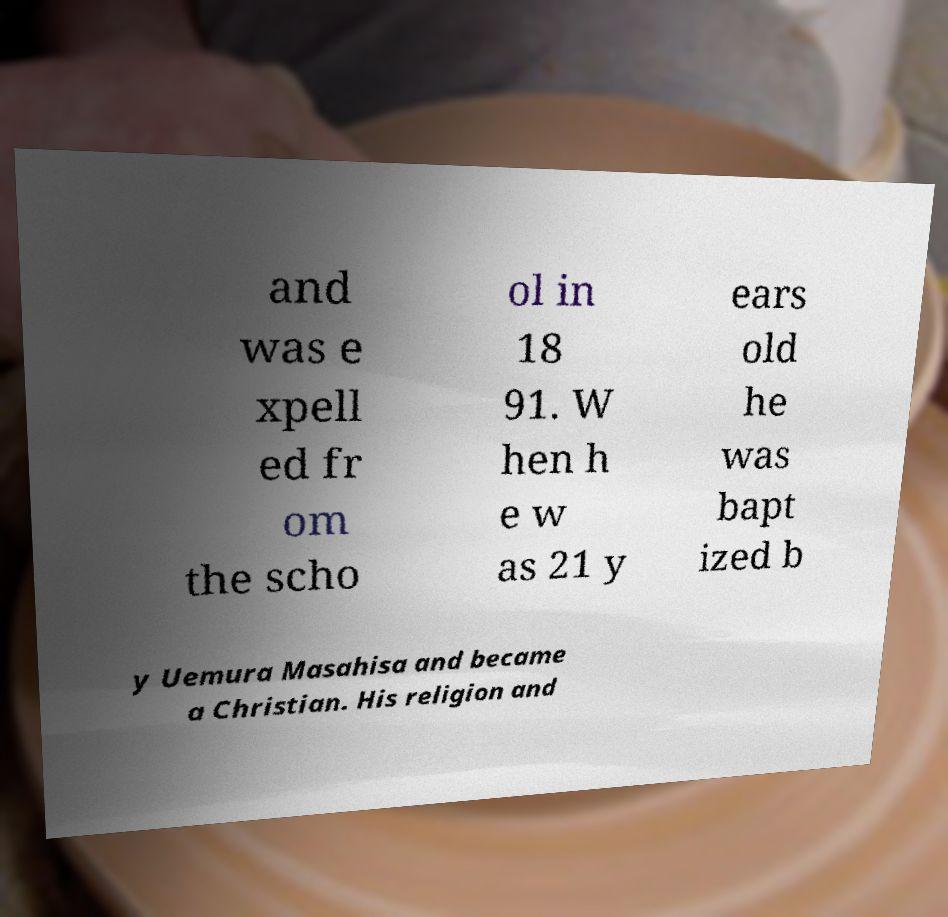Please identify and transcribe the text found in this image. and was e xpell ed fr om the scho ol in 18 91. W hen h e w as 21 y ears old he was bapt ized b y Uemura Masahisa and became a Christian. His religion and 